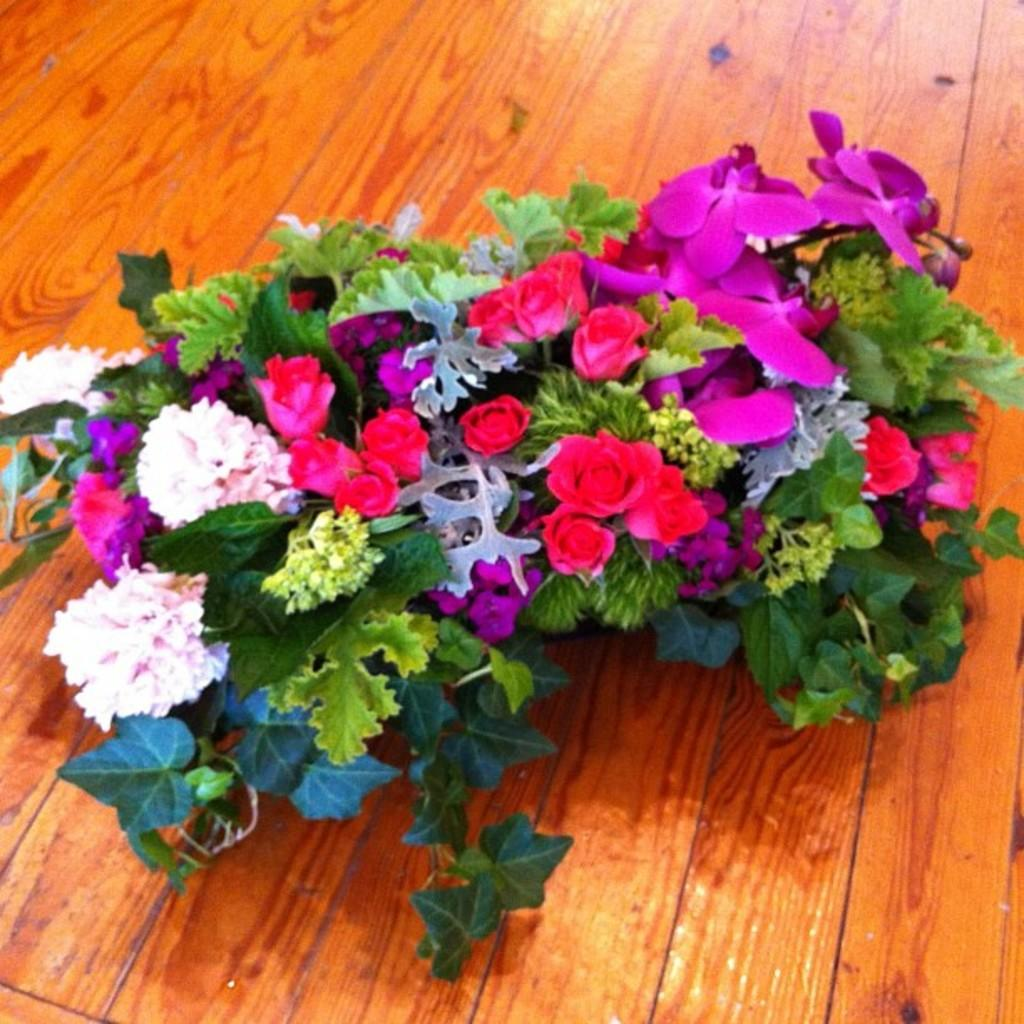What is the color of the surface in the image? The surface in the image is brown. What decorative elements are present on the surface? There are flowers on the surface. What colors are the flowers? The flowers are white, pink, and red. What other elements can be seen on the surface? There are leaves visible in the image. What type of silk material is used to make the flowers in the image? There is no silk material present in the image; the flowers are likely made of a different material or are real flowers. 